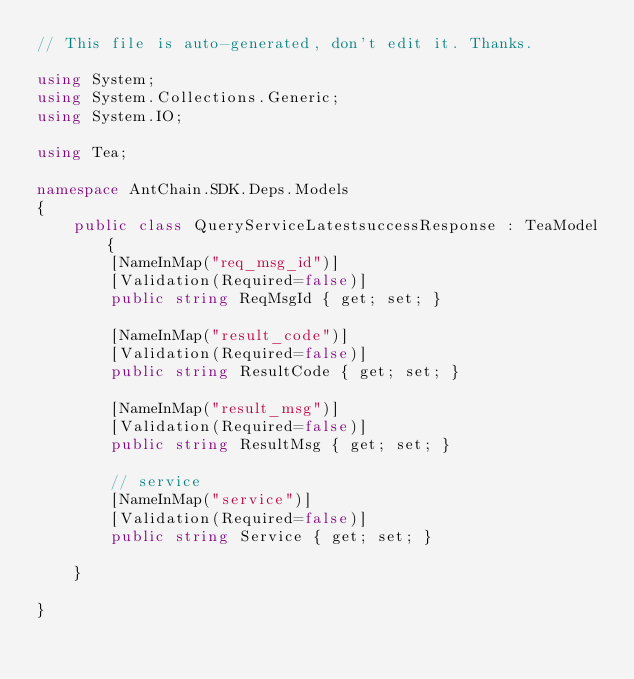Convert code to text. <code><loc_0><loc_0><loc_500><loc_500><_C#_>// This file is auto-generated, don't edit it. Thanks.

using System;
using System.Collections.Generic;
using System.IO;

using Tea;

namespace AntChain.SDK.Deps.Models
{
    public class QueryServiceLatestsuccessResponse : TeaModel {
        [NameInMap("req_msg_id")]
        [Validation(Required=false)]
        public string ReqMsgId { get; set; }

        [NameInMap("result_code")]
        [Validation(Required=false)]
        public string ResultCode { get; set; }

        [NameInMap("result_msg")]
        [Validation(Required=false)]
        public string ResultMsg { get; set; }

        // service
        [NameInMap("service")]
        [Validation(Required=false)]
        public string Service { get; set; }

    }

}
</code> 